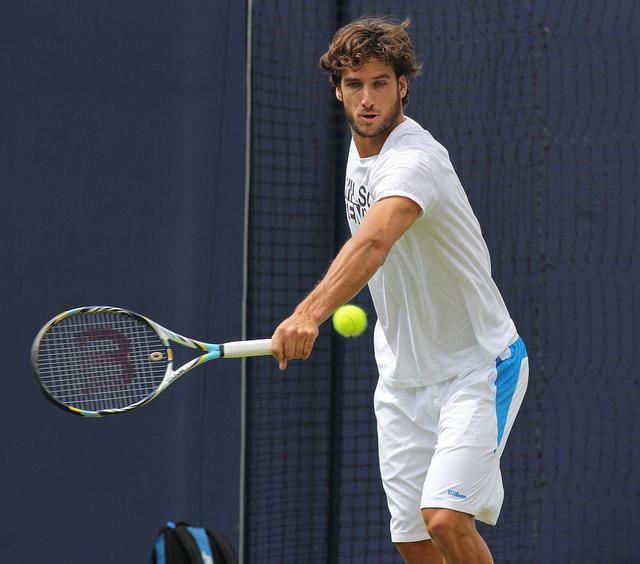How many backpacks are in the picture?
Give a very brief answer. 1. 